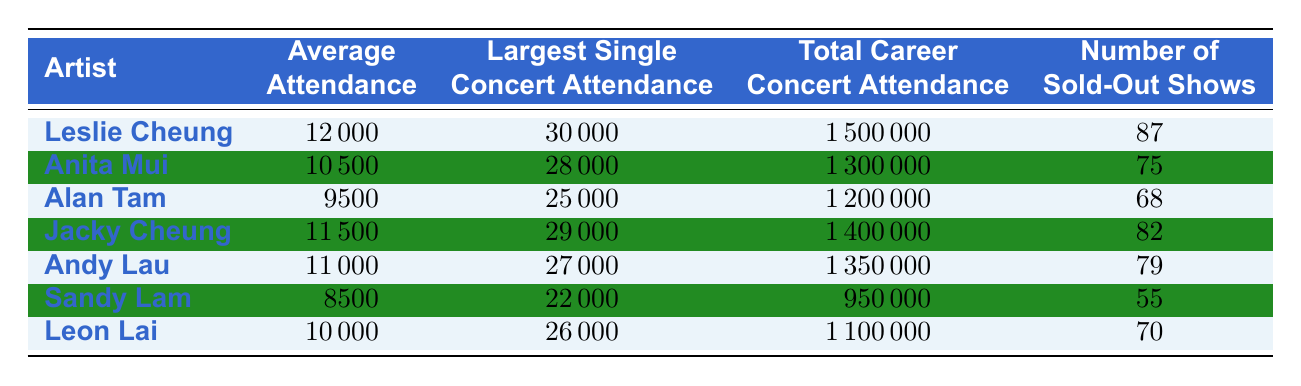What is the average attendance per concert for Leslie Cheung? The table shows that Leslie Cheung has an average attendance of 12000 per concert, which is directly listed under the "Average Attendance per Concert" column.
Answer: 12000 How many sold-out shows did Leslie Cheung have? According to the table, Leslie Cheung had 87 sold-out shows, which is stated explicitly in the "Number of Sold-Out Shows" column.
Answer: 87 Who had the largest single concert attendance among the listed artists? Leslie Cheung had the largest single concert attendance with a figure of 30000, as seen in the "Largest Single Concert Attendance" column.
Answer: Leslie Cheung Which artist had the lowest average attendance per concert? By comparing the "Average Attendance per Concert" values, Sandy Lam has the lowest with 8500. This can be confirmed by examining the average attendance figures in the respective column.
Answer: Sandy Lam What is the difference in total career concert attendance between Leslie Cheung and Sandy Lam? Leslie Cheung's total career concert attendance is 1500000, while Sandy Lam's is 950000. The difference is calculated as 1500000 - 950000 = 550000.
Answer: 550000 Did Anita Mui have more sold-out shows than Alan Tam? Anita Mui had 75 sold-out shows and Alan Tam had 68 sold-out shows. Since 75 is greater than 68, the statement is true.
Answer: Yes Which artist had a total career concert attendance of over 1400000? By inspecting the "Total Career Concert Attendance" column, both Leslie Cheung (1500000) and Jacky Cheung (1400000) have figures over 1400000.
Answer: Leslie Cheung and Jacky Cheung What is the average attendance per concert of the top three artists with the highest figures? The top three artists are Leslie Cheung (12000), Jacky Cheung (11500), and Andy Lau (11000). The total average attendance is (12000 + 11500 + 11000) / 3 = 11500.
Answer: 11500 Is it true that Alan Tam had a larger single concert attendance than Andy Lau? From the table, Alan Tam had a largest single concert attendance of 25000, while Andy Lau had 27000. Since 25000 is less than 27000, the statement is false.
Answer: No 